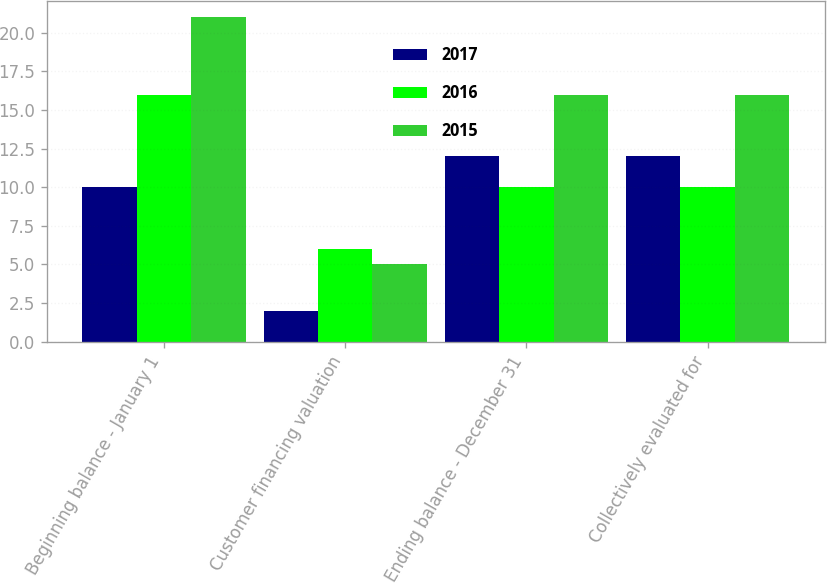<chart> <loc_0><loc_0><loc_500><loc_500><stacked_bar_chart><ecel><fcel>Beginning balance - January 1<fcel>Customer financing valuation<fcel>Ending balance - December 31<fcel>Collectively evaluated for<nl><fcel>2017<fcel>10<fcel>2<fcel>12<fcel>12<nl><fcel>2016<fcel>16<fcel>6<fcel>10<fcel>10<nl><fcel>2015<fcel>21<fcel>5<fcel>16<fcel>16<nl></chart> 